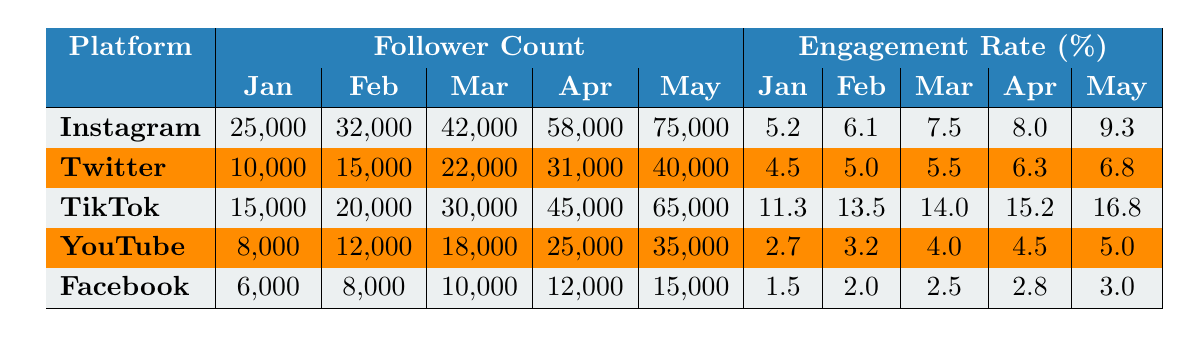What is the follower count on Instagram in May 2023? The table shows the follower count on Instagram in the column for May as 75,000.
Answer: 75,000 What was the highest engagement rate among the platforms for April 2023? For April 2023, TikTok has the highest engagement rate at 15.2%.
Answer: 15.2% What is the engagement rate increase on TikTok from January to May 2023? The engagement rate increased from 11.3% in January to 16.8% in May, which is 16.8% - 11.3% = 5.5%.
Answer: 5.5% Which platform had the lowest follower count in January 2023? In January 2023, Facebook had the lowest follower count at 6,000.
Answer: 6,000 Is the engagement rate on YouTube greater than that on Facebook for every month listed? Comparing the engagement rates, YouTube's rates (2.7%, 3.2%, 4.0%, 4.5%, 5.0%) are greater than Facebook's rates (1.5%, 2.0%, 2.5%, 2.8%, 3.0%) for every month.
Answer: Yes What is the average follower increase for Twitter from January to May 2023? The follower counts in May (40,000) and January (10,000) show an increase of 40,000 - 10,000 = 30,000 and averaging over 5 months gives an average increase of 30,000 / 4 = 7,500.
Answer: 7,500 Which platform had the highest engagement rate in January 2023? In January 2023, TikTok has the highest engagement rate at 11.3%.
Answer: 11.3% What is the difference in follower count between Instagram and TikTok in March 2023? In March 2023, Instagram had 42,000 followers and TikTok had 30,000, giving a difference of 42,000 - 30,000 = 12,000.
Answer: 12,000 Did the engagement rate for Facebook increase from January to May 2023? Facebook's engagement rate increased from 1.5% in January to 3.0% in May, indicating an increase.
Answer: Yes Which platform has the largest number of followers in May 2023? In May 2023, Instagram has the largest number of followers at 75,000.
Answer: Instagram 